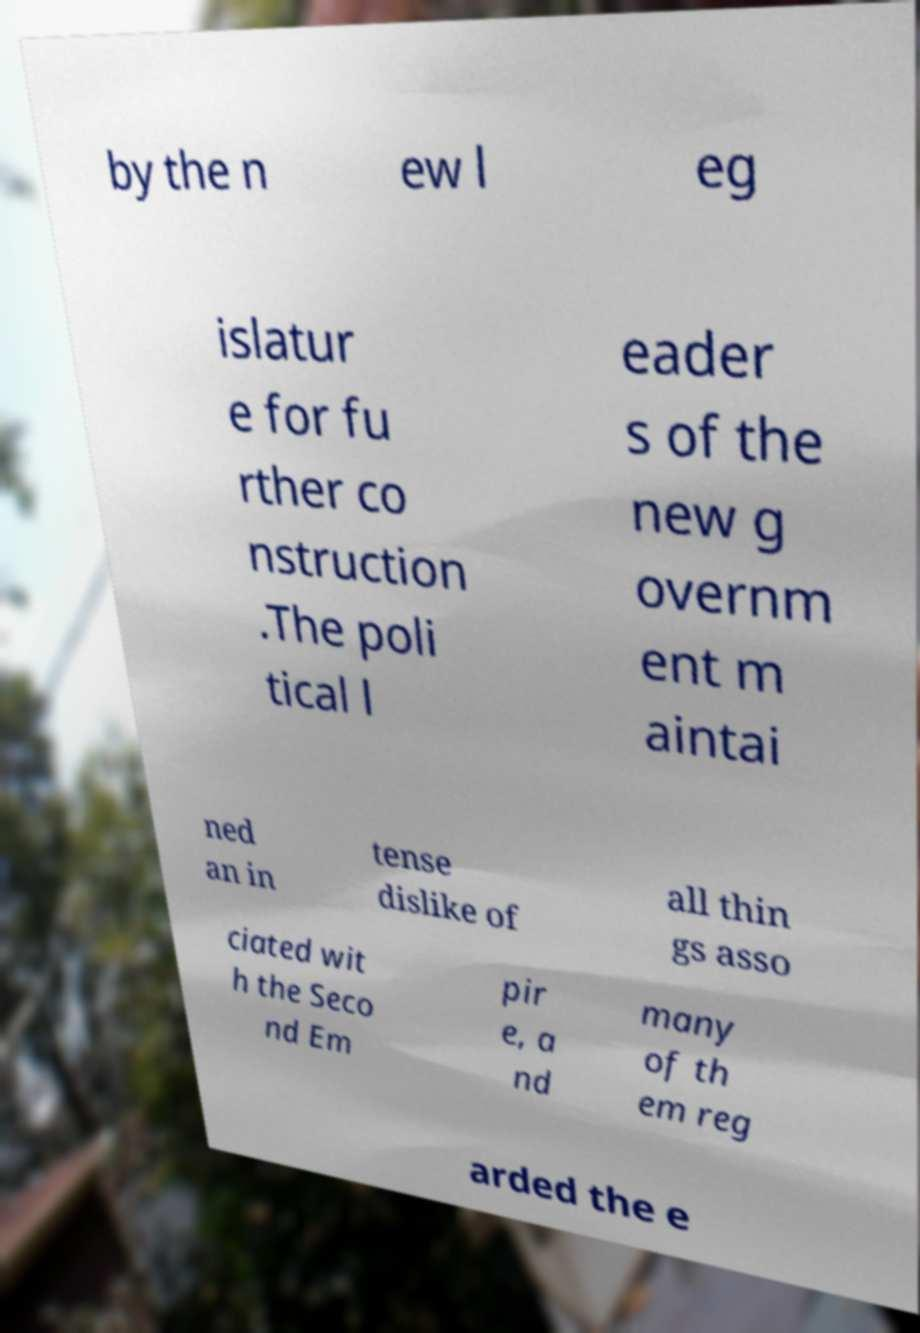What messages or text are displayed in this image? I need them in a readable, typed format. by the n ew l eg islatur e for fu rther co nstruction .The poli tical l eader s of the new g overnm ent m aintai ned an in tense dislike of all thin gs asso ciated wit h the Seco nd Em pir e, a nd many of th em reg arded the e 